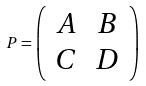Convert formula to latex. <formula><loc_0><loc_0><loc_500><loc_500>P = \left ( \begin{array} { c c } A & B \\ C & D \end{array} \right )</formula> 